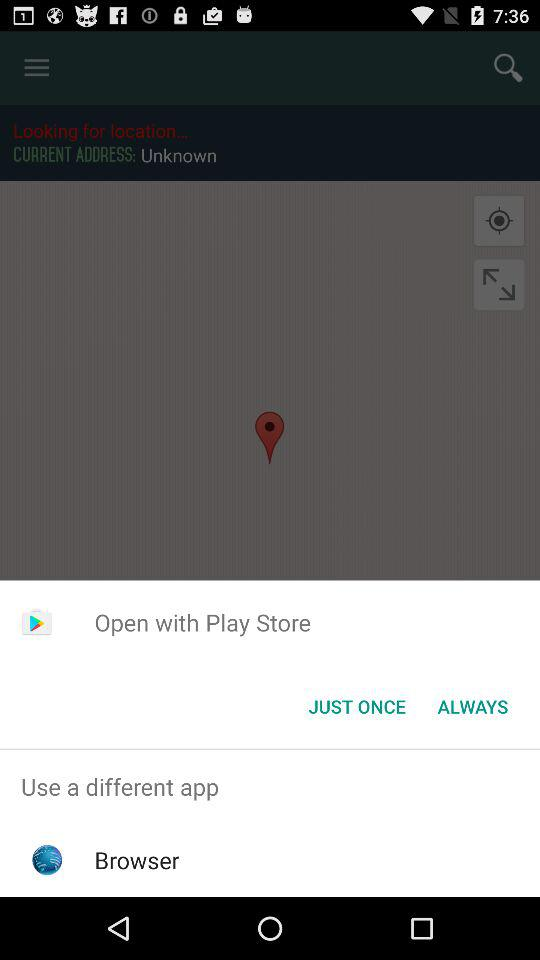How many navigation items are there in the top right corner?
Answer the question using a single word or phrase. 2 